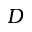<formula> <loc_0><loc_0><loc_500><loc_500>D</formula> 